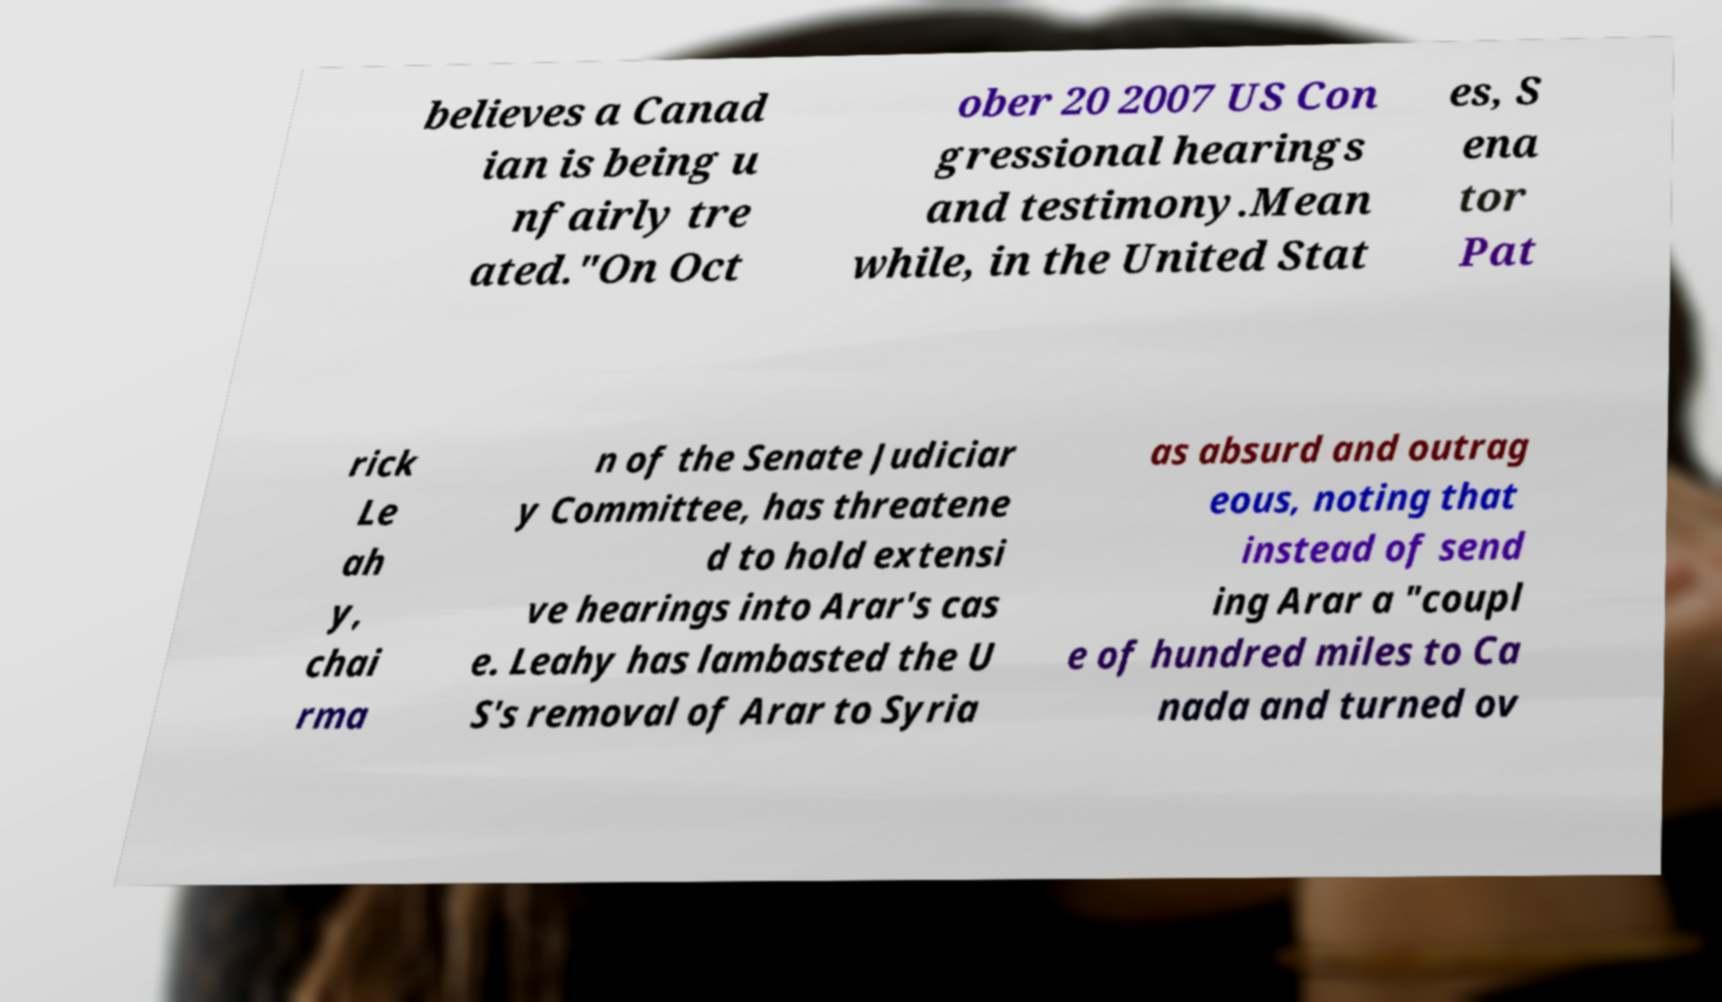Please read and relay the text visible in this image. What does it say? believes a Canad ian is being u nfairly tre ated."On Oct ober 20 2007 US Con gressional hearings and testimony.Mean while, in the United Stat es, S ena tor Pat rick Le ah y, chai rma n of the Senate Judiciar y Committee, has threatene d to hold extensi ve hearings into Arar's cas e. Leahy has lambasted the U S's removal of Arar to Syria as absurd and outrag eous, noting that instead of send ing Arar a "coupl e of hundred miles to Ca nada and turned ov 